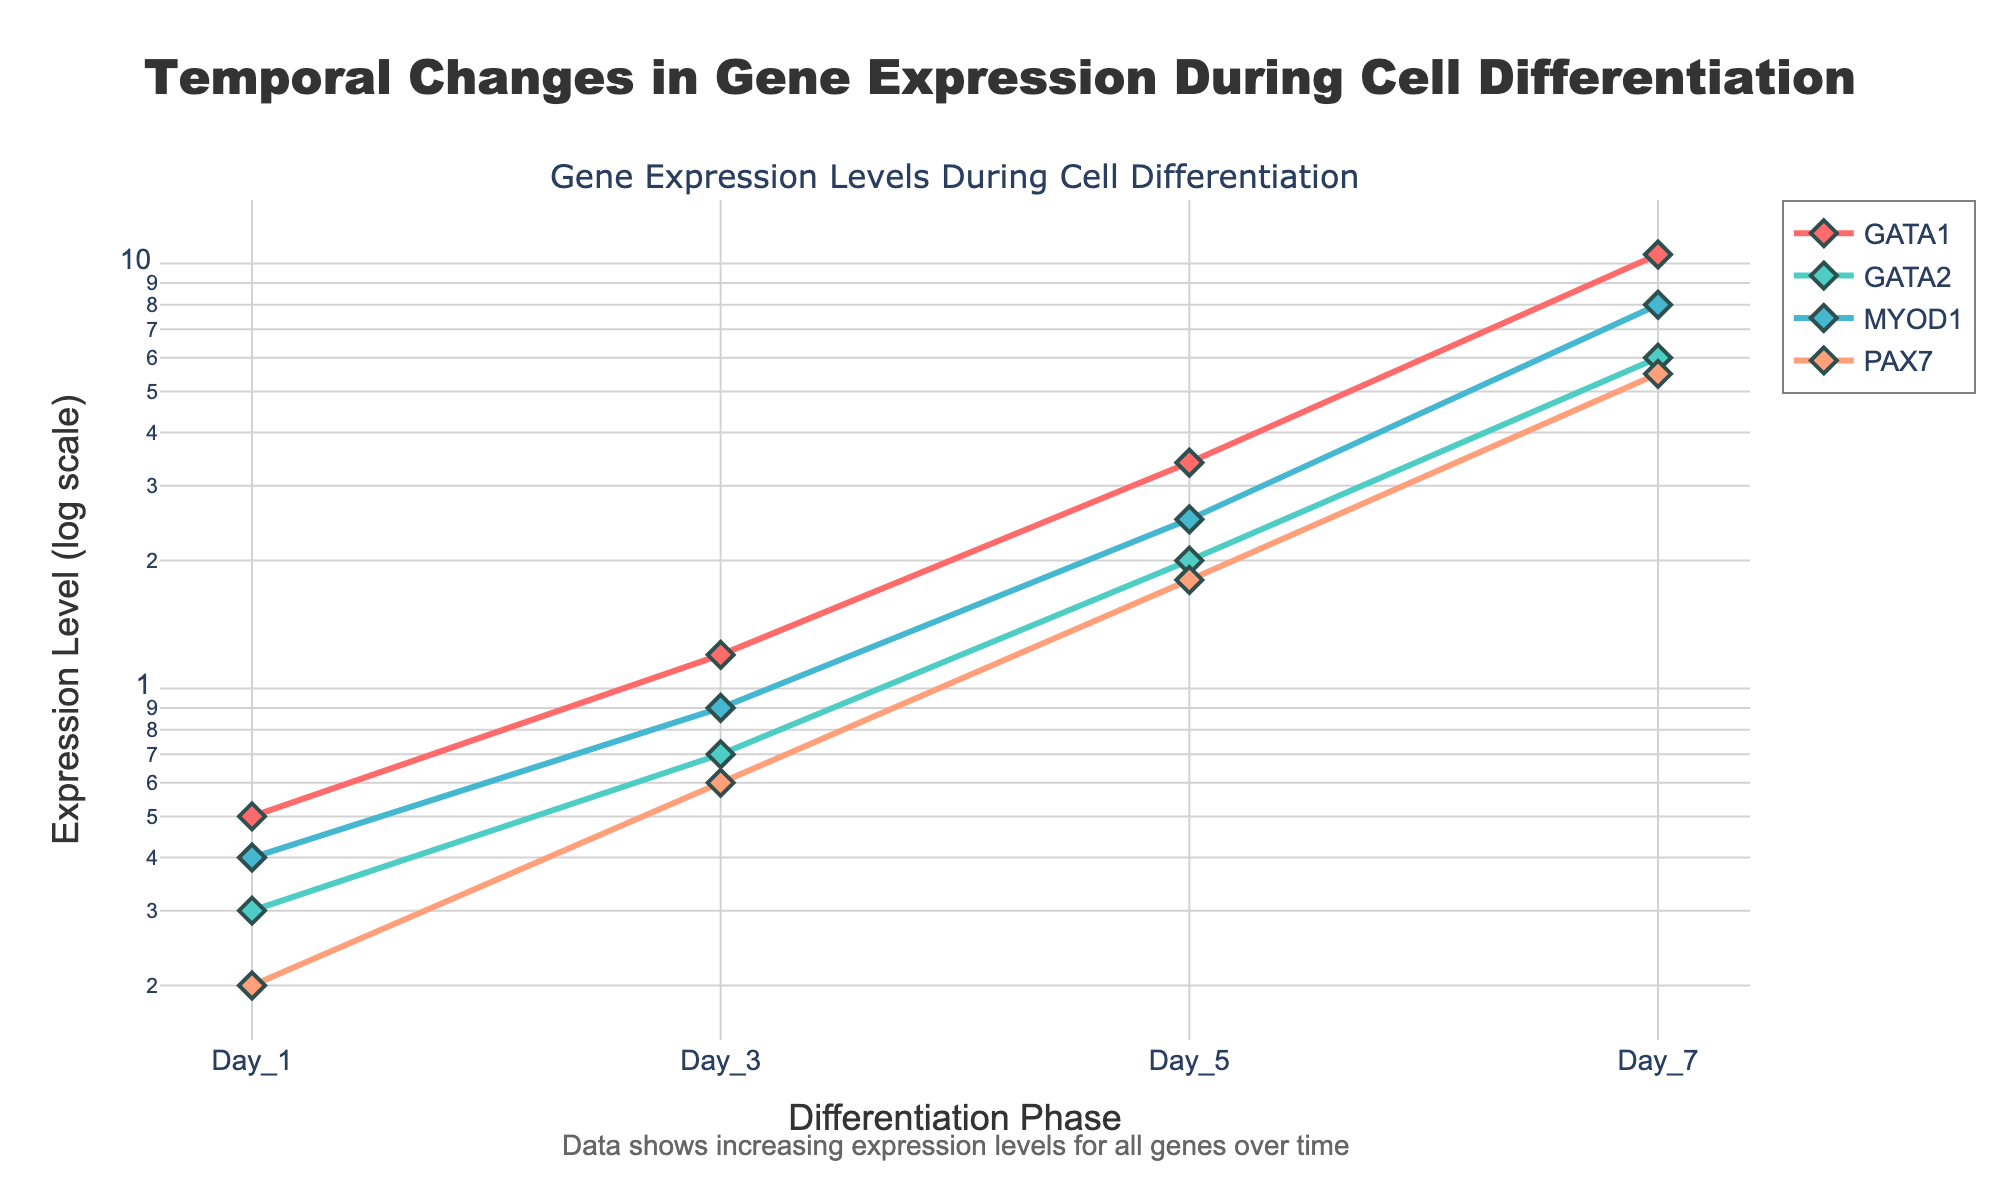What is the title of the plot? The title is usually located at the top of the plot. It provides a short description of the data visualization. The title in this plot is "Temporal Changes in Gene Expression During Cell Differentiation."
Answer: Temporal Changes in Gene Expression During Cell Differentiation Which gene has the highest expression level on Day 7? From the figure, we look at the y-values for Day 7 across all genes. GATA1 has the highest expression on Day 7.
Answer: GATA1 How does the expression level of MYOD1 change from Day 1 to Day 7? Trace the line for MYOD1, and observe the values from Day 1 (0.4) to Day 7 (8.0). There is an increasing trend.
Answer: Increases What is the general trend in gene expression levels over time? By looking at all lines in the figure, we see that the expression levels for all genes increase over time. This indicates an upward trend for each gene.
Answer: Increasing Which gene has the lowest expression level on Day 3? By comparing the y-values for all genes on Day 3, PAX7 has the lowest expression level at 0.6.
Answer: PAX7 What is the difference in expression levels of GATA2 between Day 7 and Day 1? Subtract the expression level of GATA2 on Day 1 (0.3) from its expression level on Day 7 (6.0). \(6.0 - 0.3 = 5.7\).
Answer: 5.7 Between Days 3 and 5, which gene shows the highest increase in expression level? Calculate the difference in expression levels between Day 3 and Day 5 for all genes. GATA1 has an increase of 2.2 (3.4 - 1.2), which is the highest.
Answer: GATA1 What is the pattern of change for PAX7’s expression levels over the observed period? Trace the line for PAX7 and observe the values at each time point: from 0.2 on Day 1 to 5.5 on Day 7. The expression levels steadily increase over time.
Answer: Steadily increases Which gene shows the smallest change in expression between the initial phase (Day 1) and the final phase (Day 7)? Calculate the difference for each gene from Day 1 to Day 7. PAX7 changes from 0.2 to 5.5, a difference of 5.3. This is the smallest change.
Answer: PAX7 On which day do all genes exhibit more than a 10-fold increase in expression levels from their initial (Day 1) levels? Examine the fold change for each gene by checking the y-values across all phases. On Day 7, every gene shows more than a 10-fold increase from their initial levels.
Answer: Day 7 